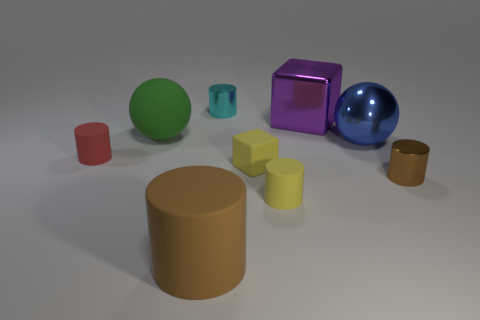What is the shape of the other big thing that is the same material as the large brown object?
Keep it short and to the point. Sphere. Are there any other things that have the same color as the shiny ball?
Your response must be concise. No. There is another brown object that is the same shape as the tiny brown shiny thing; what material is it?
Your answer should be compact. Rubber. How many other things are the same size as the yellow block?
Offer a very short reply. 4. Do the small metal object that is to the right of the blue ball and the brown rubber object have the same shape?
Offer a very short reply. Yes. What number of other objects are the same shape as the brown metallic thing?
Give a very brief answer. 4. The tiny thing that is to the left of the cyan shiny thing has what shape?
Your answer should be compact. Cylinder. Is there a ball that has the same material as the small red cylinder?
Ensure brevity in your answer.  Yes. There is a shiny thing that is in front of the small block; does it have the same color as the large matte cylinder?
Give a very brief answer. Yes. What size is the red matte thing?
Ensure brevity in your answer.  Small. 